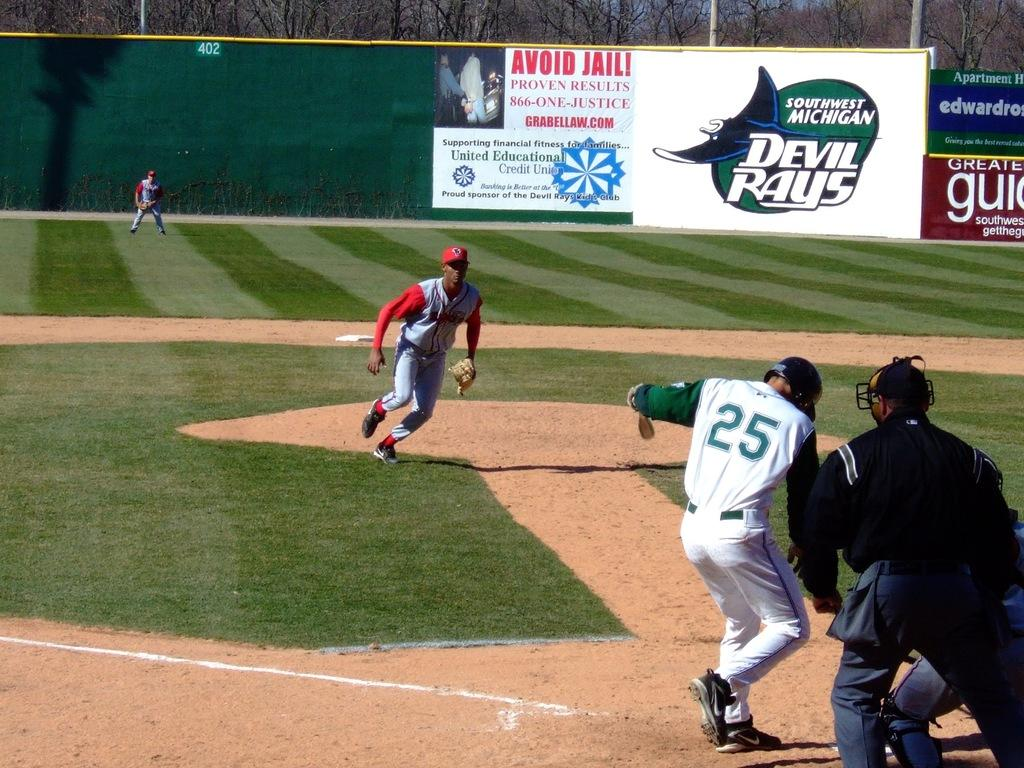<image>
Offer a succinct explanation of the picture presented. A baseball player with the number 25 on his jersey is at home plate. 